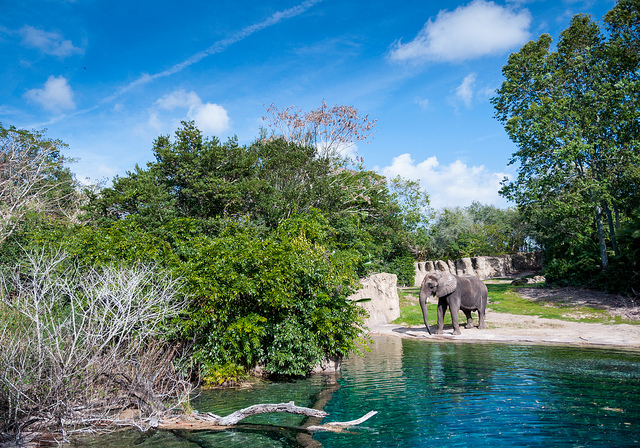<image>What city is this picture taken in? It is ambiguous what city this picture is taken in. What city is this picture taken in? I am not sure what city this picture is taken in. It could be Houston, New York, Cape Town, Los Angeles, Austin, Honolulu, Milano, or Toledo. 